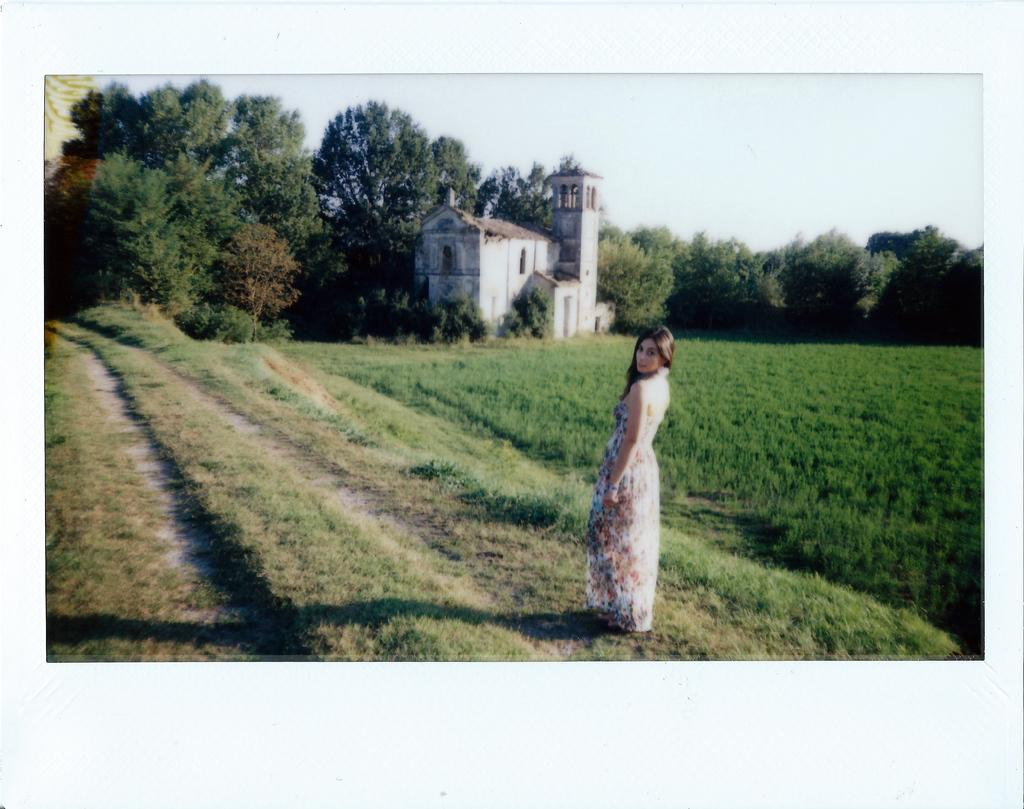What is the main subject of the image? There is a person standing in the center of the image. How is the person dressed in the image? The person is wearing a different costume. What can be seen in the background of the image? There is sky, trees, at least one building, and grass visible in the background of the image. What letter can be seen on the roof of the building in the image? There is no letter visible on the roof of the building in the image. 